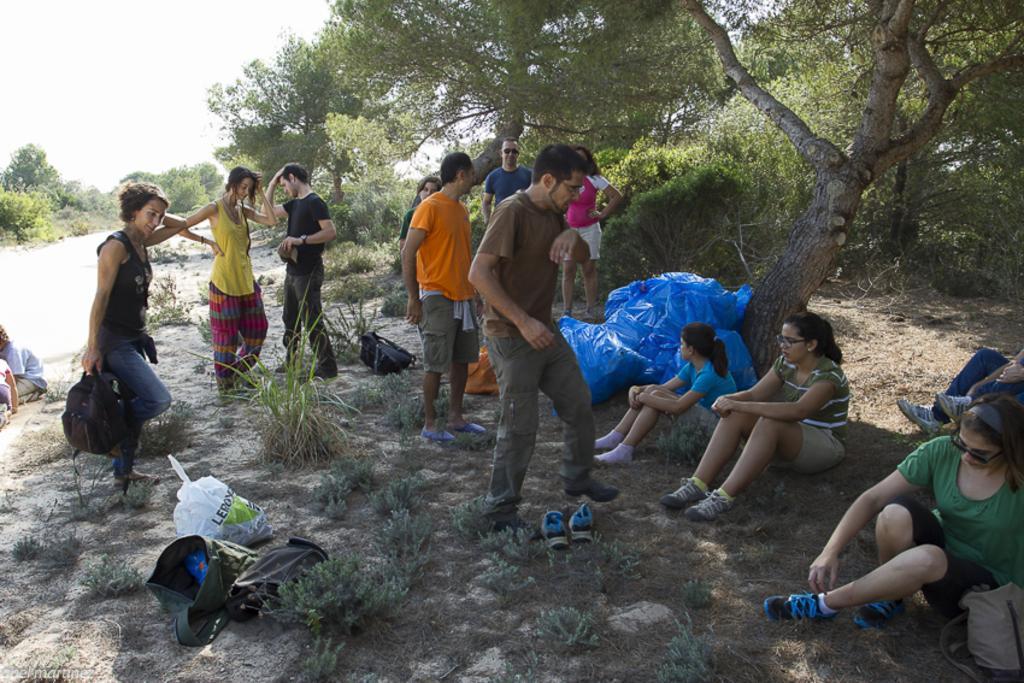How would you summarize this image in a sentence or two? In this picture there are group of people sitting and there are group of people standing. In the foreground there are bags and there is a cover and footwear. At the back there are trees. At the top there is sky. At the bottom there is grass. 